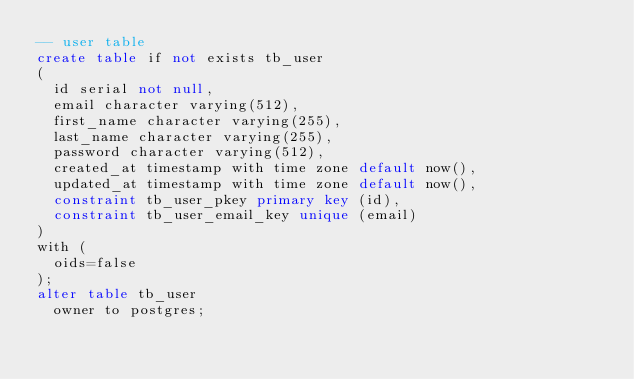<code> <loc_0><loc_0><loc_500><loc_500><_SQL_>-- user table
create table if not exists tb_user
(
  id serial not null,
  email character varying(512),
  first_name character varying(255),
  last_name character varying(255),
  password character varying(512),
  created_at timestamp with time zone default now(),
  updated_at timestamp with time zone default now(),
  constraint tb_user_pkey primary key (id),
  constraint tb_user_email_key unique (email)
)
with (
  oids=false
);
alter table tb_user
  owner to postgres;

</code> 